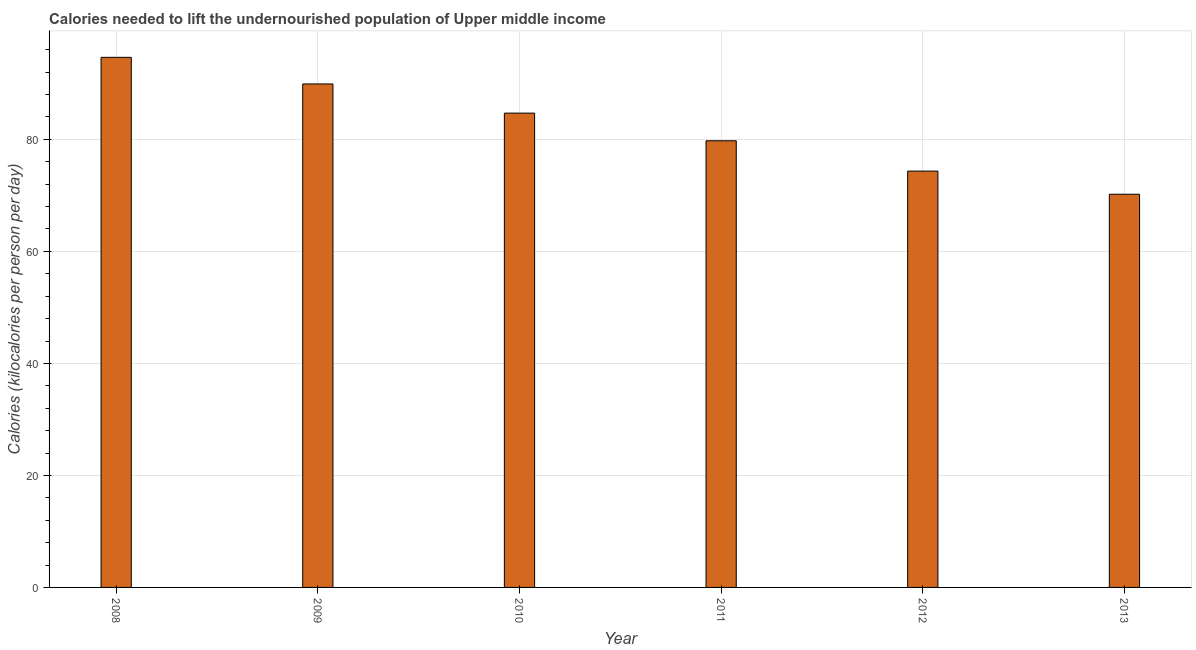Does the graph contain any zero values?
Offer a very short reply. No. Does the graph contain grids?
Keep it short and to the point. Yes. What is the title of the graph?
Ensure brevity in your answer.  Calories needed to lift the undernourished population of Upper middle income. What is the label or title of the Y-axis?
Provide a short and direct response. Calories (kilocalories per person per day). What is the depth of food deficit in 2012?
Your answer should be very brief. 74.34. Across all years, what is the maximum depth of food deficit?
Ensure brevity in your answer.  94.65. Across all years, what is the minimum depth of food deficit?
Give a very brief answer. 70.2. In which year was the depth of food deficit maximum?
Offer a very short reply. 2008. What is the sum of the depth of food deficit?
Your response must be concise. 493.53. What is the difference between the depth of food deficit in 2009 and 2010?
Your response must be concise. 5.21. What is the average depth of food deficit per year?
Make the answer very short. 82.26. What is the median depth of food deficit?
Keep it short and to the point. 82.22. In how many years, is the depth of food deficit greater than 28 kilocalories?
Your response must be concise. 6. Do a majority of the years between 2010 and 2012 (inclusive) have depth of food deficit greater than 28 kilocalories?
Offer a terse response. Yes. What is the ratio of the depth of food deficit in 2010 to that in 2013?
Keep it short and to the point. 1.21. What is the difference between the highest and the second highest depth of food deficit?
Your answer should be very brief. 4.75. What is the difference between the highest and the lowest depth of food deficit?
Make the answer very short. 24.45. Are all the bars in the graph horizontal?
Provide a short and direct response. No. How many years are there in the graph?
Your answer should be very brief. 6. What is the difference between two consecutive major ticks on the Y-axis?
Your answer should be compact. 20. Are the values on the major ticks of Y-axis written in scientific E-notation?
Keep it short and to the point. No. What is the Calories (kilocalories per person per day) in 2008?
Make the answer very short. 94.65. What is the Calories (kilocalories per person per day) in 2009?
Your answer should be compact. 89.9. What is the Calories (kilocalories per person per day) in 2010?
Offer a terse response. 84.69. What is the Calories (kilocalories per person per day) of 2011?
Provide a short and direct response. 79.75. What is the Calories (kilocalories per person per day) of 2012?
Give a very brief answer. 74.34. What is the Calories (kilocalories per person per day) of 2013?
Offer a very short reply. 70.2. What is the difference between the Calories (kilocalories per person per day) in 2008 and 2009?
Your answer should be compact. 4.75. What is the difference between the Calories (kilocalories per person per day) in 2008 and 2010?
Your response must be concise. 9.96. What is the difference between the Calories (kilocalories per person per day) in 2008 and 2011?
Keep it short and to the point. 14.9. What is the difference between the Calories (kilocalories per person per day) in 2008 and 2012?
Provide a succinct answer. 20.31. What is the difference between the Calories (kilocalories per person per day) in 2008 and 2013?
Provide a short and direct response. 24.45. What is the difference between the Calories (kilocalories per person per day) in 2009 and 2010?
Keep it short and to the point. 5.21. What is the difference between the Calories (kilocalories per person per day) in 2009 and 2011?
Your answer should be very brief. 10.15. What is the difference between the Calories (kilocalories per person per day) in 2009 and 2012?
Offer a very short reply. 15.56. What is the difference between the Calories (kilocalories per person per day) in 2009 and 2013?
Ensure brevity in your answer.  19.7. What is the difference between the Calories (kilocalories per person per day) in 2010 and 2011?
Give a very brief answer. 4.94. What is the difference between the Calories (kilocalories per person per day) in 2010 and 2012?
Keep it short and to the point. 10.35. What is the difference between the Calories (kilocalories per person per day) in 2010 and 2013?
Your answer should be very brief. 14.49. What is the difference between the Calories (kilocalories per person per day) in 2011 and 2012?
Your answer should be very brief. 5.41. What is the difference between the Calories (kilocalories per person per day) in 2011 and 2013?
Offer a terse response. 9.55. What is the difference between the Calories (kilocalories per person per day) in 2012 and 2013?
Your answer should be very brief. 4.13. What is the ratio of the Calories (kilocalories per person per day) in 2008 to that in 2009?
Your answer should be compact. 1.05. What is the ratio of the Calories (kilocalories per person per day) in 2008 to that in 2010?
Your answer should be very brief. 1.12. What is the ratio of the Calories (kilocalories per person per day) in 2008 to that in 2011?
Provide a short and direct response. 1.19. What is the ratio of the Calories (kilocalories per person per day) in 2008 to that in 2012?
Provide a succinct answer. 1.27. What is the ratio of the Calories (kilocalories per person per day) in 2008 to that in 2013?
Keep it short and to the point. 1.35. What is the ratio of the Calories (kilocalories per person per day) in 2009 to that in 2010?
Ensure brevity in your answer.  1.06. What is the ratio of the Calories (kilocalories per person per day) in 2009 to that in 2011?
Your answer should be compact. 1.13. What is the ratio of the Calories (kilocalories per person per day) in 2009 to that in 2012?
Your answer should be very brief. 1.21. What is the ratio of the Calories (kilocalories per person per day) in 2009 to that in 2013?
Provide a succinct answer. 1.28. What is the ratio of the Calories (kilocalories per person per day) in 2010 to that in 2011?
Provide a short and direct response. 1.06. What is the ratio of the Calories (kilocalories per person per day) in 2010 to that in 2012?
Make the answer very short. 1.14. What is the ratio of the Calories (kilocalories per person per day) in 2010 to that in 2013?
Your response must be concise. 1.21. What is the ratio of the Calories (kilocalories per person per day) in 2011 to that in 2012?
Ensure brevity in your answer.  1.07. What is the ratio of the Calories (kilocalories per person per day) in 2011 to that in 2013?
Your response must be concise. 1.14. What is the ratio of the Calories (kilocalories per person per day) in 2012 to that in 2013?
Your answer should be compact. 1.06. 